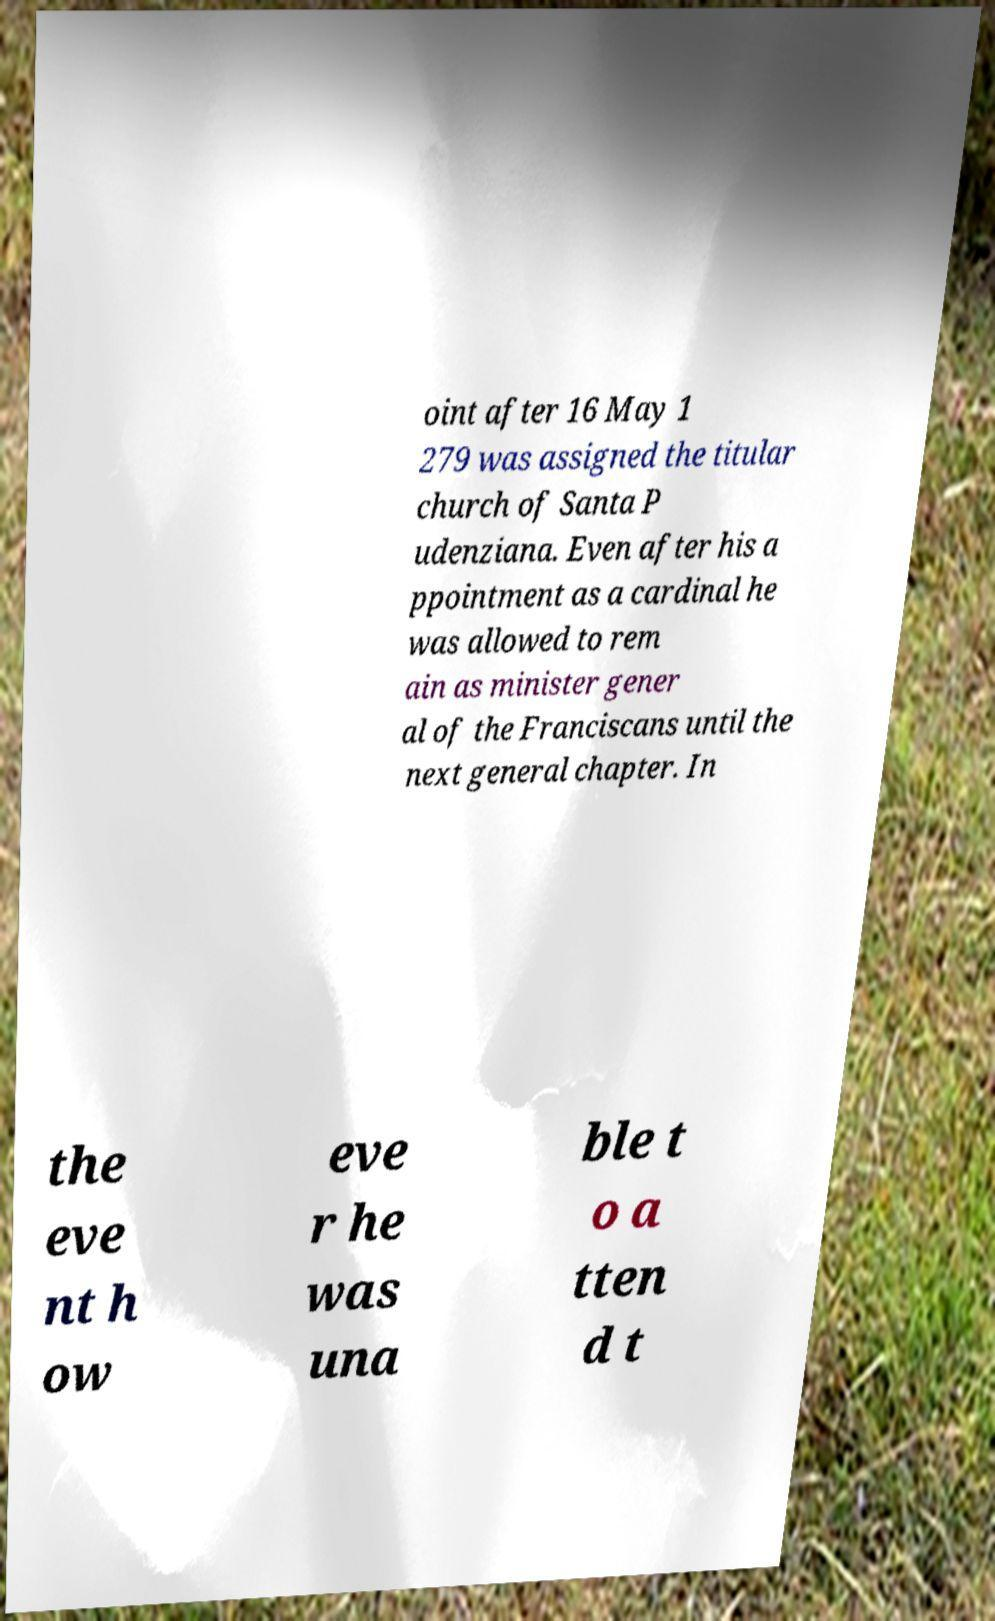What messages or text are displayed in this image? I need them in a readable, typed format. oint after 16 May 1 279 was assigned the titular church of Santa P udenziana. Even after his a ppointment as a cardinal he was allowed to rem ain as minister gener al of the Franciscans until the next general chapter. In the eve nt h ow eve r he was una ble t o a tten d t 